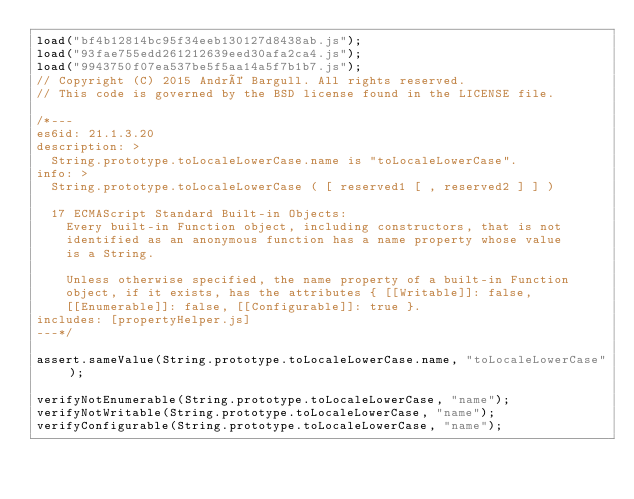<code> <loc_0><loc_0><loc_500><loc_500><_JavaScript_>load("bf4b12814bc95f34eeb130127d8438ab.js");
load("93fae755edd261212639eed30afa2ca4.js");
load("9943750f07ea537be5f5aa14a5f7b1b7.js");
// Copyright (C) 2015 André Bargull. All rights reserved.
// This code is governed by the BSD license found in the LICENSE file.

/*---
es6id: 21.1.3.20
description: >
  String.prototype.toLocaleLowerCase.name is "toLocaleLowerCase".
info: >
  String.prototype.toLocaleLowerCase ( [ reserved1 [ , reserved2 ] ] )

  17 ECMAScript Standard Built-in Objects:
    Every built-in Function object, including constructors, that is not
    identified as an anonymous function has a name property whose value
    is a String.

    Unless otherwise specified, the name property of a built-in Function
    object, if it exists, has the attributes { [[Writable]]: false,
    [[Enumerable]]: false, [[Configurable]]: true }.
includes: [propertyHelper.js]
---*/

assert.sameValue(String.prototype.toLocaleLowerCase.name, "toLocaleLowerCase");

verifyNotEnumerable(String.prototype.toLocaleLowerCase, "name");
verifyNotWritable(String.prototype.toLocaleLowerCase, "name");
verifyConfigurable(String.prototype.toLocaleLowerCase, "name");
</code> 